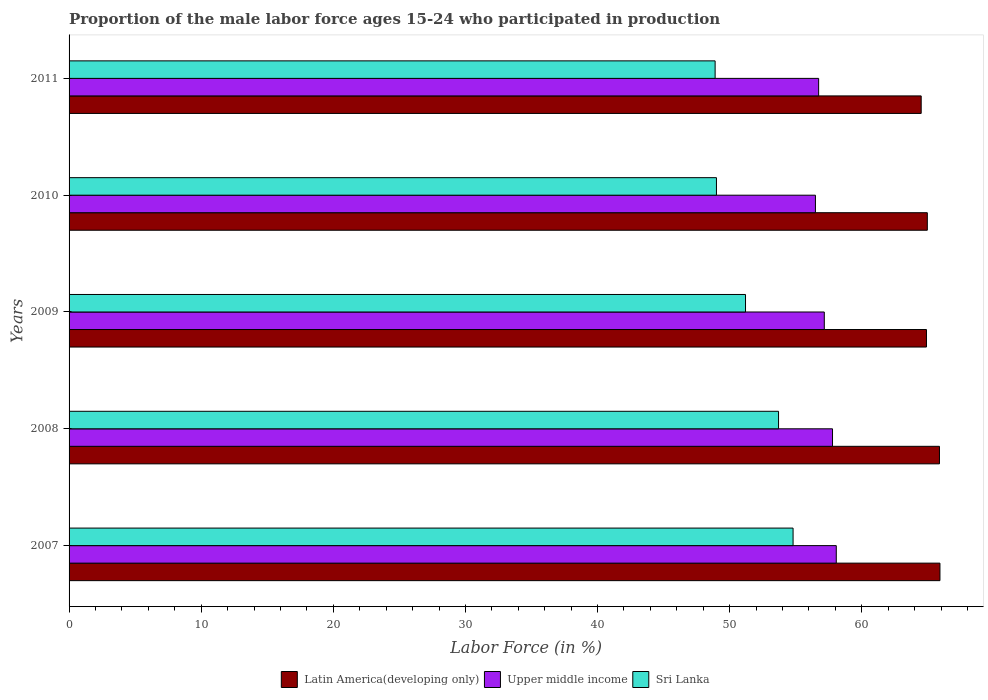How many groups of bars are there?
Your answer should be very brief. 5. Are the number of bars per tick equal to the number of legend labels?
Your answer should be very brief. Yes. Are the number of bars on each tick of the Y-axis equal?
Offer a very short reply. Yes. How many bars are there on the 1st tick from the bottom?
Provide a succinct answer. 3. In how many cases, is the number of bars for a given year not equal to the number of legend labels?
Keep it short and to the point. 0. What is the proportion of the male labor force who participated in production in Sri Lanka in 2010?
Your answer should be very brief. 49. Across all years, what is the maximum proportion of the male labor force who participated in production in Sri Lanka?
Give a very brief answer. 54.8. Across all years, what is the minimum proportion of the male labor force who participated in production in Sri Lanka?
Provide a succinct answer. 48.9. What is the total proportion of the male labor force who participated in production in Upper middle income in the graph?
Give a very brief answer. 286.24. What is the difference between the proportion of the male labor force who participated in production in Sri Lanka in 2008 and that in 2011?
Your answer should be very brief. 4.8. What is the difference between the proportion of the male labor force who participated in production in Sri Lanka in 2010 and the proportion of the male labor force who participated in production in Upper middle income in 2007?
Keep it short and to the point. -9.07. What is the average proportion of the male labor force who participated in production in Latin America(developing only) per year?
Your answer should be very brief. 65.23. In the year 2008, what is the difference between the proportion of the male labor force who participated in production in Sri Lanka and proportion of the male labor force who participated in production in Latin America(developing only)?
Your response must be concise. -12.18. In how many years, is the proportion of the male labor force who participated in production in Upper middle income greater than 24 %?
Provide a short and direct response. 5. What is the ratio of the proportion of the male labor force who participated in production in Upper middle income in 2009 to that in 2011?
Provide a succinct answer. 1.01. Is the proportion of the male labor force who participated in production in Sri Lanka in 2008 less than that in 2011?
Offer a very short reply. No. What is the difference between the highest and the second highest proportion of the male labor force who participated in production in Sri Lanka?
Offer a terse response. 1.1. What is the difference between the highest and the lowest proportion of the male labor force who participated in production in Sri Lanka?
Your answer should be compact. 5.9. In how many years, is the proportion of the male labor force who participated in production in Sri Lanka greater than the average proportion of the male labor force who participated in production in Sri Lanka taken over all years?
Provide a succinct answer. 2. What does the 3rd bar from the top in 2009 represents?
Keep it short and to the point. Latin America(developing only). What does the 2nd bar from the bottom in 2011 represents?
Offer a very short reply. Upper middle income. Are all the bars in the graph horizontal?
Your response must be concise. Yes. What is the difference between two consecutive major ticks on the X-axis?
Ensure brevity in your answer.  10. Are the values on the major ticks of X-axis written in scientific E-notation?
Offer a terse response. No. Where does the legend appear in the graph?
Keep it short and to the point. Bottom center. How many legend labels are there?
Offer a very short reply. 3. What is the title of the graph?
Ensure brevity in your answer.  Proportion of the male labor force ages 15-24 who participated in production. Does "Cameroon" appear as one of the legend labels in the graph?
Offer a very short reply. No. What is the label or title of the Y-axis?
Provide a succinct answer. Years. What is the Labor Force (in %) of Latin America(developing only) in 2007?
Offer a terse response. 65.92. What is the Labor Force (in %) of Upper middle income in 2007?
Give a very brief answer. 58.07. What is the Labor Force (in %) in Sri Lanka in 2007?
Your answer should be compact. 54.8. What is the Labor Force (in %) of Latin America(developing only) in 2008?
Give a very brief answer. 65.88. What is the Labor Force (in %) in Upper middle income in 2008?
Ensure brevity in your answer.  57.78. What is the Labor Force (in %) in Sri Lanka in 2008?
Offer a terse response. 53.7. What is the Labor Force (in %) of Latin America(developing only) in 2009?
Make the answer very short. 64.9. What is the Labor Force (in %) of Upper middle income in 2009?
Make the answer very short. 57.16. What is the Labor Force (in %) of Sri Lanka in 2009?
Provide a succinct answer. 51.2. What is the Labor Force (in %) of Latin America(developing only) in 2010?
Offer a very short reply. 64.96. What is the Labor Force (in %) of Upper middle income in 2010?
Make the answer very short. 56.49. What is the Labor Force (in %) in Latin America(developing only) in 2011?
Ensure brevity in your answer.  64.5. What is the Labor Force (in %) of Upper middle income in 2011?
Offer a very short reply. 56.73. What is the Labor Force (in %) in Sri Lanka in 2011?
Make the answer very short. 48.9. Across all years, what is the maximum Labor Force (in %) in Latin America(developing only)?
Your response must be concise. 65.92. Across all years, what is the maximum Labor Force (in %) in Upper middle income?
Provide a succinct answer. 58.07. Across all years, what is the maximum Labor Force (in %) in Sri Lanka?
Provide a short and direct response. 54.8. Across all years, what is the minimum Labor Force (in %) of Latin America(developing only)?
Keep it short and to the point. 64.5. Across all years, what is the minimum Labor Force (in %) of Upper middle income?
Offer a very short reply. 56.49. Across all years, what is the minimum Labor Force (in %) in Sri Lanka?
Provide a short and direct response. 48.9. What is the total Labor Force (in %) in Latin America(developing only) in the graph?
Your answer should be very brief. 326.15. What is the total Labor Force (in %) of Upper middle income in the graph?
Your response must be concise. 286.24. What is the total Labor Force (in %) in Sri Lanka in the graph?
Your response must be concise. 257.6. What is the difference between the Labor Force (in %) in Latin America(developing only) in 2007 and that in 2008?
Give a very brief answer. 0.04. What is the difference between the Labor Force (in %) in Upper middle income in 2007 and that in 2008?
Ensure brevity in your answer.  0.28. What is the difference between the Labor Force (in %) in Sri Lanka in 2007 and that in 2008?
Make the answer very short. 1.1. What is the difference between the Labor Force (in %) in Latin America(developing only) in 2007 and that in 2009?
Offer a very short reply. 1.02. What is the difference between the Labor Force (in %) of Upper middle income in 2007 and that in 2009?
Ensure brevity in your answer.  0.91. What is the difference between the Labor Force (in %) in Latin America(developing only) in 2007 and that in 2010?
Your answer should be very brief. 0.96. What is the difference between the Labor Force (in %) of Upper middle income in 2007 and that in 2010?
Your answer should be very brief. 1.58. What is the difference between the Labor Force (in %) of Latin America(developing only) in 2007 and that in 2011?
Provide a succinct answer. 1.42. What is the difference between the Labor Force (in %) in Upper middle income in 2007 and that in 2011?
Your answer should be compact. 1.33. What is the difference between the Labor Force (in %) of Sri Lanka in 2007 and that in 2011?
Offer a terse response. 5.9. What is the difference between the Labor Force (in %) of Latin America(developing only) in 2008 and that in 2009?
Give a very brief answer. 0.98. What is the difference between the Labor Force (in %) of Upper middle income in 2008 and that in 2009?
Your answer should be compact. 0.62. What is the difference between the Labor Force (in %) in Sri Lanka in 2008 and that in 2009?
Offer a terse response. 2.5. What is the difference between the Labor Force (in %) in Latin America(developing only) in 2008 and that in 2010?
Provide a short and direct response. 0.92. What is the difference between the Labor Force (in %) in Upper middle income in 2008 and that in 2010?
Make the answer very short. 1.29. What is the difference between the Labor Force (in %) of Latin America(developing only) in 2008 and that in 2011?
Ensure brevity in your answer.  1.38. What is the difference between the Labor Force (in %) in Upper middle income in 2008 and that in 2011?
Your answer should be compact. 1.05. What is the difference between the Labor Force (in %) of Latin America(developing only) in 2009 and that in 2010?
Provide a short and direct response. -0.06. What is the difference between the Labor Force (in %) in Upper middle income in 2009 and that in 2010?
Keep it short and to the point. 0.67. What is the difference between the Labor Force (in %) of Latin America(developing only) in 2009 and that in 2011?
Provide a succinct answer. 0.4. What is the difference between the Labor Force (in %) in Upper middle income in 2009 and that in 2011?
Your answer should be compact. 0.43. What is the difference between the Labor Force (in %) of Sri Lanka in 2009 and that in 2011?
Ensure brevity in your answer.  2.3. What is the difference between the Labor Force (in %) in Latin America(developing only) in 2010 and that in 2011?
Offer a terse response. 0.46. What is the difference between the Labor Force (in %) of Upper middle income in 2010 and that in 2011?
Make the answer very short. -0.24. What is the difference between the Labor Force (in %) in Sri Lanka in 2010 and that in 2011?
Your answer should be compact. 0.1. What is the difference between the Labor Force (in %) in Latin America(developing only) in 2007 and the Labor Force (in %) in Upper middle income in 2008?
Provide a succinct answer. 8.13. What is the difference between the Labor Force (in %) of Latin America(developing only) in 2007 and the Labor Force (in %) of Sri Lanka in 2008?
Keep it short and to the point. 12.22. What is the difference between the Labor Force (in %) of Upper middle income in 2007 and the Labor Force (in %) of Sri Lanka in 2008?
Ensure brevity in your answer.  4.37. What is the difference between the Labor Force (in %) of Latin America(developing only) in 2007 and the Labor Force (in %) of Upper middle income in 2009?
Provide a succinct answer. 8.75. What is the difference between the Labor Force (in %) in Latin America(developing only) in 2007 and the Labor Force (in %) in Sri Lanka in 2009?
Your answer should be compact. 14.72. What is the difference between the Labor Force (in %) of Upper middle income in 2007 and the Labor Force (in %) of Sri Lanka in 2009?
Your response must be concise. 6.87. What is the difference between the Labor Force (in %) of Latin America(developing only) in 2007 and the Labor Force (in %) of Upper middle income in 2010?
Provide a short and direct response. 9.42. What is the difference between the Labor Force (in %) in Latin America(developing only) in 2007 and the Labor Force (in %) in Sri Lanka in 2010?
Your answer should be compact. 16.92. What is the difference between the Labor Force (in %) in Upper middle income in 2007 and the Labor Force (in %) in Sri Lanka in 2010?
Keep it short and to the point. 9.07. What is the difference between the Labor Force (in %) in Latin America(developing only) in 2007 and the Labor Force (in %) in Upper middle income in 2011?
Your answer should be very brief. 9.18. What is the difference between the Labor Force (in %) in Latin America(developing only) in 2007 and the Labor Force (in %) in Sri Lanka in 2011?
Your answer should be very brief. 17.02. What is the difference between the Labor Force (in %) of Upper middle income in 2007 and the Labor Force (in %) of Sri Lanka in 2011?
Your response must be concise. 9.17. What is the difference between the Labor Force (in %) of Latin America(developing only) in 2008 and the Labor Force (in %) of Upper middle income in 2009?
Make the answer very short. 8.72. What is the difference between the Labor Force (in %) of Latin America(developing only) in 2008 and the Labor Force (in %) of Sri Lanka in 2009?
Provide a short and direct response. 14.68. What is the difference between the Labor Force (in %) in Upper middle income in 2008 and the Labor Force (in %) in Sri Lanka in 2009?
Your answer should be very brief. 6.58. What is the difference between the Labor Force (in %) of Latin America(developing only) in 2008 and the Labor Force (in %) of Upper middle income in 2010?
Keep it short and to the point. 9.39. What is the difference between the Labor Force (in %) of Latin America(developing only) in 2008 and the Labor Force (in %) of Sri Lanka in 2010?
Provide a short and direct response. 16.88. What is the difference between the Labor Force (in %) in Upper middle income in 2008 and the Labor Force (in %) in Sri Lanka in 2010?
Ensure brevity in your answer.  8.78. What is the difference between the Labor Force (in %) in Latin America(developing only) in 2008 and the Labor Force (in %) in Upper middle income in 2011?
Ensure brevity in your answer.  9.15. What is the difference between the Labor Force (in %) of Latin America(developing only) in 2008 and the Labor Force (in %) of Sri Lanka in 2011?
Your answer should be very brief. 16.98. What is the difference between the Labor Force (in %) in Upper middle income in 2008 and the Labor Force (in %) in Sri Lanka in 2011?
Make the answer very short. 8.88. What is the difference between the Labor Force (in %) in Latin America(developing only) in 2009 and the Labor Force (in %) in Upper middle income in 2010?
Ensure brevity in your answer.  8.4. What is the difference between the Labor Force (in %) in Latin America(developing only) in 2009 and the Labor Force (in %) in Sri Lanka in 2010?
Provide a succinct answer. 15.9. What is the difference between the Labor Force (in %) of Upper middle income in 2009 and the Labor Force (in %) of Sri Lanka in 2010?
Provide a short and direct response. 8.16. What is the difference between the Labor Force (in %) in Latin America(developing only) in 2009 and the Labor Force (in %) in Upper middle income in 2011?
Give a very brief answer. 8.16. What is the difference between the Labor Force (in %) in Latin America(developing only) in 2009 and the Labor Force (in %) in Sri Lanka in 2011?
Your response must be concise. 16. What is the difference between the Labor Force (in %) in Upper middle income in 2009 and the Labor Force (in %) in Sri Lanka in 2011?
Offer a very short reply. 8.26. What is the difference between the Labor Force (in %) of Latin America(developing only) in 2010 and the Labor Force (in %) of Upper middle income in 2011?
Keep it short and to the point. 8.23. What is the difference between the Labor Force (in %) in Latin America(developing only) in 2010 and the Labor Force (in %) in Sri Lanka in 2011?
Provide a short and direct response. 16.06. What is the difference between the Labor Force (in %) in Upper middle income in 2010 and the Labor Force (in %) in Sri Lanka in 2011?
Offer a terse response. 7.59. What is the average Labor Force (in %) in Latin America(developing only) per year?
Your answer should be compact. 65.23. What is the average Labor Force (in %) in Upper middle income per year?
Your response must be concise. 57.25. What is the average Labor Force (in %) in Sri Lanka per year?
Make the answer very short. 51.52. In the year 2007, what is the difference between the Labor Force (in %) in Latin America(developing only) and Labor Force (in %) in Upper middle income?
Ensure brevity in your answer.  7.85. In the year 2007, what is the difference between the Labor Force (in %) of Latin America(developing only) and Labor Force (in %) of Sri Lanka?
Make the answer very short. 11.12. In the year 2007, what is the difference between the Labor Force (in %) in Upper middle income and Labor Force (in %) in Sri Lanka?
Give a very brief answer. 3.27. In the year 2008, what is the difference between the Labor Force (in %) in Latin America(developing only) and Labor Force (in %) in Upper middle income?
Offer a very short reply. 8.1. In the year 2008, what is the difference between the Labor Force (in %) in Latin America(developing only) and Labor Force (in %) in Sri Lanka?
Your answer should be compact. 12.18. In the year 2008, what is the difference between the Labor Force (in %) in Upper middle income and Labor Force (in %) in Sri Lanka?
Offer a terse response. 4.08. In the year 2009, what is the difference between the Labor Force (in %) of Latin America(developing only) and Labor Force (in %) of Upper middle income?
Give a very brief answer. 7.73. In the year 2009, what is the difference between the Labor Force (in %) in Latin America(developing only) and Labor Force (in %) in Sri Lanka?
Give a very brief answer. 13.7. In the year 2009, what is the difference between the Labor Force (in %) of Upper middle income and Labor Force (in %) of Sri Lanka?
Your answer should be very brief. 5.96. In the year 2010, what is the difference between the Labor Force (in %) of Latin America(developing only) and Labor Force (in %) of Upper middle income?
Give a very brief answer. 8.47. In the year 2010, what is the difference between the Labor Force (in %) of Latin America(developing only) and Labor Force (in %) of Sri Lanka?
Keep it short and to the point. 15.96. In the year 2010, what is the difference between the Labor Force (in %) of Upper middle income and Labor Force (in %) of Sri Lanka?
Offer a terse response. 7.49. In the year 2011, what is the difference between the Labor Force (in %) in Latin America(developing only) and Labor Force (in %) in Upper middle income?
Offer a terse response. 7.76. In the year 2011, what is the difference between the Labor Force (in %) of Latin America(developing only) and Labor Force (in %) of Sri Lanka?
Make the answer very short. 15.6. In the year 2011, what is the difference between the Labor Force (in %) in Upper middle income and Labor Force (in %) in Sri Lanka?
Your answer should be compact. 7.83. What is the ratio of the Labor Force (in %) in Latin America(developing only) in 2007 to that in 2008?
Make the answer very short. 1. What is the ratio of the Labor Force (in %) of Upper middle income in 2007 to that in 2008?
Your response must be concise. 1. What is the ratio of the Labor Force (in %) in Sri Lanka in 2007 to that in 2008?
Your answer should be very brief. 1.02. What is the ratio of the Labor Force (in %) of Latin America(developing only) in 2007 to that in 2009?
Provide a short and direct response. 1.02. What is the ratio of the Labor Force (in %) in Upper middle income in 2007 to that in 2009?
Provide a short and direct response. 1.02. What is the ratio of the Labor Force (in %) of Sri Lanka in 2007 to that in 2009?
Your response must be concise. 1.07. What is the ratio of the Labor Force (in %) of Latin America(developing only) in 2007 to that in 2010?
Ensure brevity in your answer.  1.01. What is the ratio of the Labor Force (in %) in Upper middle income in 2007 to that in 2010?
Your answer should be compact. 1.03. What is the ratio of the Labor Force (in %) in Sri Lanka in 2007 to that in 2010?
Make the answer very short. 1.12. What is the ratio of the Labor Force (in %) of Latin America(developing only) in 2007 to that in 2011?
Give a very brief answer. 1.02. What is the ratio of the Labor Force (in %) of Upper middle income in 2007 to that in 2011?
Provide a short and direct response. 1.02. What is the ratio of the Labor Force (in %) in Sri Lanka in 2007 to that in 2011?
Give a very brief answer. 1.12. What is the ratio of the Labor Force (in %) in Latin America(developing only) in 2008 to that in 2009?
Make the answer very short. 1.02. What is the ratio of the Labor Force (in %) of Upper middle income in 2008 to that in 2009?
Make the answer very short. 1.01. What is the ratio of the Labor Force (in %) of Sri Lanka in 2008 to that in 2009?
Provide a succinct answer. 1.05. What is the ratio of the Labor Force (in %) in Latin America(developing only) in 2008 to that in 2010?
Provide a short and direct response. 1.01. What is the ratio of the Labor Force (in %) in Upper middle income in 2008 to that in 2010?
Make the answer very short. 1.02. What is the ratio of the Labor Force (in %) of Sri Lanka in 2008 to that in 2010?
Make the answer very short. 1.1. What is the ratio of the Labor Force (in %) in Latin America(developing only) in 2008 to that in 2011?
Make the answer very short. 1.02. What is the ratio of the Labor Force (in %) of Upper middle income in 2008 to that in 2011?
Provide a succinct answer. 1.02. What is the ratio of the Labor Force (in %) of Sri Lanka in 2008 to that in 2011?
Provide a short and direct response. 1.1. What is the ratio of the Labor Force (in %) of Latin America(developing only) in 2009 to that in 2010?
Provide a succinct answer. 1. What is the ratio of the Labor Force (in %) in Upper middle income in 2009 to that in 2010?
Give a very brief answer. 1.01. What is the ratio of the Labor Force (in %) in Sri Lanka in 2009 to that in 2010?
Give a very brief answer. 1.04. What is the ratio of the Labor Force (in %) of Upper middle income in 2009 to that in 2011?
Make the answer very short. 1.01. What is the ratio of the Labor Force (in %) in Sri Lanka in 2009 to that in 2011?
Keep it short and to the point. 1.05. What is the ratio of the Labor Force (in %) in Latin America(developing only) in 2010 to that in 2011?
Your response must be concise. 1.01. What is the difference between the highest and the second highest Labor Force (in %) of Latin America(developing only)?
Your response must be concise. 0.04. What is the difference between the highest and the second highest Labor Force (in %) of Upper middle income?
Give a very brief answer. 0.28. What is the difference between the highest and the lowest Labor Force (in %) of Latin America(developing only)?
Make the answer very short. 1.42. What is the difference between the highest and the lowest Labor Force (in %) in Upper middle income?
Make the answer very short. 1.58. What is the difference between the highest and the lowest Labor Force (in %) in Sri Lanka?
Offer a very short reply. 5.9. 